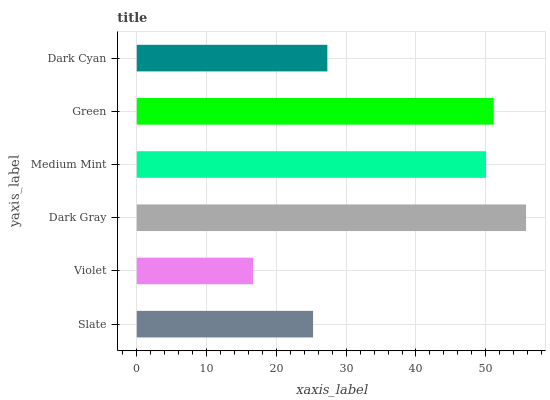Is Violet the minimum?
Answer yes or no. Yes. Is Dark Gray the maximum?
Answer yes or no. Yes. Is Dark Gray the minimum?
Answer yes or no. No. Is Violet the maximum?
Answer yes or no. No. Is Dark Gray greater than Violet?
Answer yes or no. Yes. Is Violet less than Dark Gray?
Answer yes or no. Yes. Is Violet greater than Dark Gray?
Answer yes or no. No. Is Dark Gray less than Violet?
Answer yes or no. No. Is Medium Mint the high median?
Answer yes or no. Yes. Is Dark Cyan the low median?
Answer yes or no. Yes. Is Dark Cyan the high median?
Answer yes or no. No. Is Green the low median?
Answer yes or no. No. 